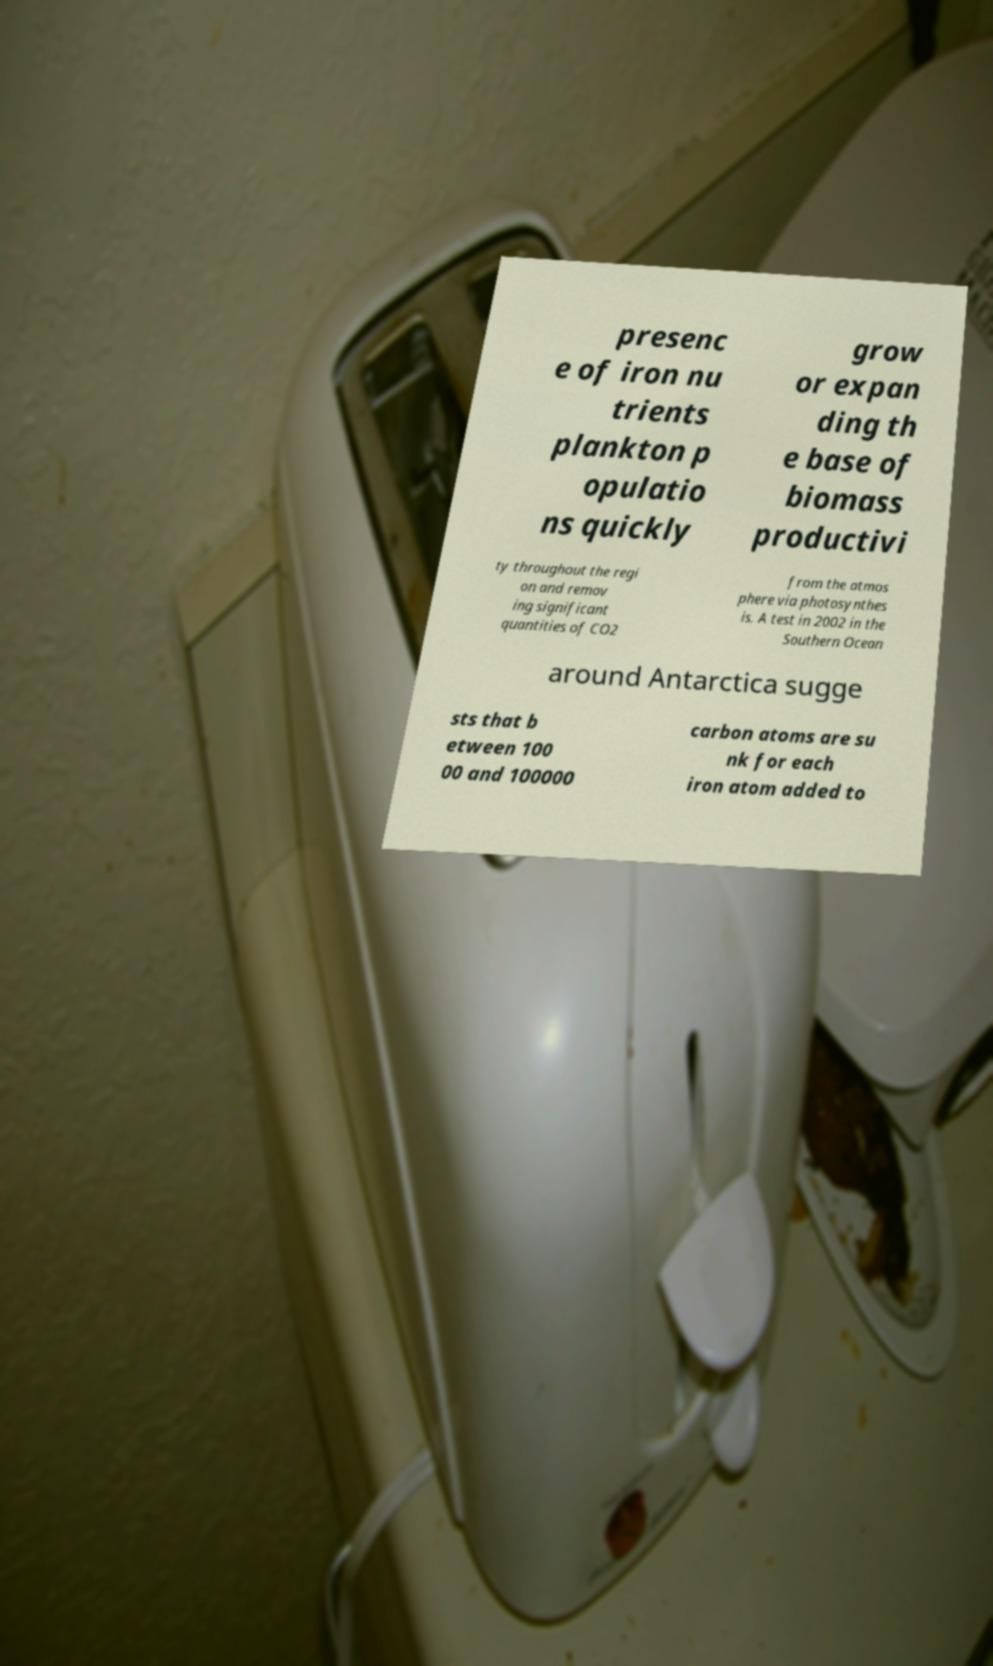Please read and relay the text visible in this image. What does it say? presenc e of iron nu trients plankton p opulatio ns quickly grow or expan ding th e base of biomass productivi ty throughout the regi on and remov ing significant quantities of CO2 from the atmos phere via photosynthes is. A test in 2002 in the Southern Ocean around Antarctica sugge sts that b etween 100 00 and 100000 carbon atoms are su nk for each iron atom added to 